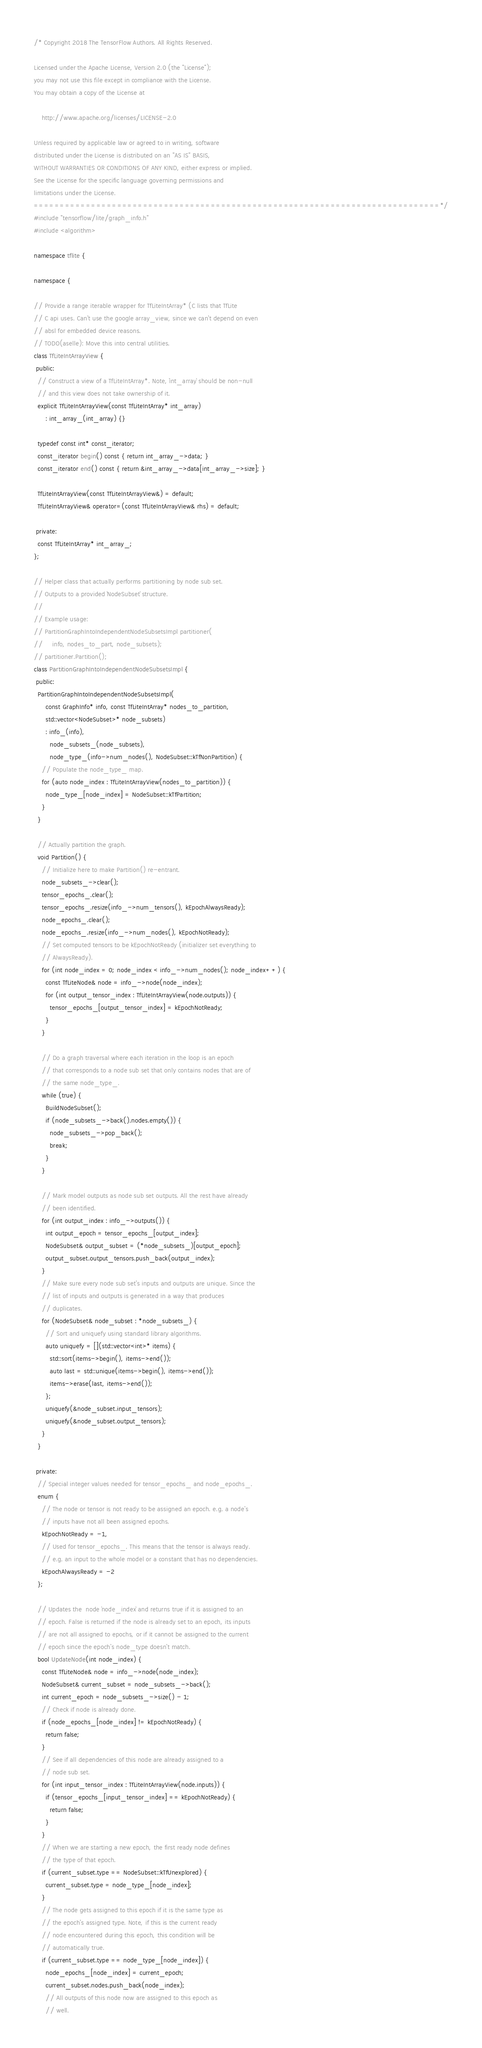<code> <loc_0><loc_0><loc_500><loc_500><_C++_>/* Copyright 2018 The TensorFlow Authors. All Rights Reserved.

Licensed under the Apache License, Version 2.0 (the "License");
you may not use this file except in compliance with the License.
You may obtain a copy of the License at

    http://www.apache.org/licenses/LICENSE-2.0

Unless required by applicable law or agreed to in writing, software
distributed under the License is distributed on an "AS IS" BASIS,
WITHOUT WARRANTIES OR CONDITIONS OF ANY KIND, either express or implied.
See the License for the specific language governing permissions and
limitations under the License.
==============================================================================*/
#include "tensorflow/lite/graph_info.h"
#include <algorithm>

namespace tflite {

namespace {

// Provide a range iterable wrapper for TfLiteIntArray* (C lists that TfLite
// C api uses. Can't use the google array_view, since we can't depend on even
// absl for embedded device reasons.
// TODO(aselle): Move this into central utilities.
class TfLiteIntArrayView {
 public:
  // Construct a view of a TfLiteIntArray*. Note, `int_array` should be non-null
  // and this view does not take ownership of it.
  explicit TfLiteIntArrayView(const TfLiteIntArray* int_array)
      : int_array_(int_array) {}

  typedef const int* const_iterator;
  const_iterator begin() const { return int_array_->data; }
  const_iterator end() const { return &int_array_->data[int_array_->size]; }

  TfLiteIntArrayView(const TfLiteIntArrayView&) = default;
  TfLiteIntArrayView& operator=(const TfLiteIntArrayView& rhs) = default;

 private:
  const TfLiteIntArray* int_array_;
};

// Helper class that actually performs partitioning by node sub set.
// Outputs to a provided `NodeSubset` structure.
//
// Example usage:
// PartitionGraphIntoIndependentNodeSubsetsImpl partitioner(
//     info, nodes_to_part, node_subsets);
// partitioner.Partition();
class PartitionGraphIntoIndependentNodeSubsetsImpl {
 public:
  PartitionGraphIntoIndependentNodeSubsetsImpl(
      const GraphInfo* info, const TfLiteIntArray* nodes_to_partition,
      std::vector<NodeSubset>* node_subsets)
      : info_(info),
        node_subsets_(node_subsets),
        node_type_(info->num_nodes(), NodeSubset::kTfNonPartition) {
    // Populate the node_type_ map.
    for (auto node_index : TfLiteIntArrayView(nodes_to_partition)) {
      node_type_[node_index] = NodeSubset::kTfPartition;
    }
  }

  // Actually partition the graph.
  void Partition() {
    // Initialize here to make Partition() re-entrant.
    node_subsets_->clear();
    tensor_epochs_.clear();
    tensor_epochs_.resize(info_->num_tensors(), kEpochAlwaysReady);
    node_epochs_.clear();
    node_epochs_.resize(info_->num_nodes(), kEpochNotReady);
    // Set computed tensors to be kEpochNotReady (initializer set everything to
    // AlwaysReady).
    for (int node_index = 0; node_index < info_->num_nodes(); node_index++) {
      const TfLiteNode& node = info_->node(node_index);
      for (int output_tensor_index : TfLiteIntArrayView(node.outputs)) {
        tensor_epochs_[output_tensor_index] = kEpochNotReady;
      }
    }

    // Do a graph traversal where each iteration in the loop is an epoch
    // that corresponds to a node sub set that only contains nodes that are of
    // the same node_type_.
    while (true) {
      BuildNodeSubset();
      if (node_subsets_->back().nodes.empty()) {
        node_subsets_->pop_back();
        break;
      }
    }

    // Mark model outputs as node sub set outputs. All the rest have already
    // been identified.
    for (int output_index : info_->outputs()) {
      int output_epoch = tensor_epochs_[output_index];
      NodeSubset& output_subset = (*node_subsets_)[output_epoch];
      output_subset.output_tensors.push_back(output_index);
    }
    // Make sure every node sub set's inputs and outputs are unique. Since the
    // list of inputs and outputs is generated in a way that produces
    // duplicates.
    for (NodeSubset& node_subset : *node_subsets_) {
      // Sort and uniquefy using standard library algorithms.
      auto uniquefy = [](std::vector<int>* items) {
        std::sort(items->begin(), items->end());
        auto last = std::unique(items->begin(), items->end());
        items->erase(last, items->end());
      };
      uniquefy(&node_subset.input_tensors);
      uniquefy(&node_subset.output_tensors);
    }
  }

 private:
  // Special integer values needed for tensor_epochs_ and node_epochs_.
  enum {
    // The node or tensor is not ready to be assigned an epoch. e.g. a node's
    // inputs have not all been assigned epochs.
    kEpochNotReady = -1,
    // Used for tensor_epochs_. This means that the tensor is always ready.
    // e.g. an input to the whole model or a constant that has no dependencies.
    kEpochAlwaysReady = -2
  };

  // Updates the  node `node_index` and returns true if it is assigned to an
  // epoch. False is returned if the node is already set to an epoch, its inputs
  // are not all assigned to epochs, or if it cannot be assigned to the current
  // epoch since the epoch's node_type doesn't match.
  bool UpdateNode(int node_index) {
    const TfLiteNode& node = info_->node(node_index);
    NodeSubset& current_subset = node_subsets_->back();
    int current_epoch = node_subsets_->size() - 1;
    // Check if node is already done.
    if (node_epochs_[node_index] != kEpochNotReady) {
      return false;
    }
    // See if all dependencies of this node are already assigned to a
    // node sub set.
    for (int input_tensor_index : TfLiteIntArrayView(node.inputs)) {
      if (tensor_epochs_[input_tensor_index] == kEpochNotReady) {
        return false;
      }
    }
    // When we are starting a new epoch, the first ready node defines
    // the type of that epoch.
    if (current_subset.type == NodeSubset::kTfUnexplored) {
      current_subset.type = node_type_[node_index];
    }
    // The node gets assigned to this epoch if it is the same type as
    // the epoch's assigned type. Note, if this is the current ready
    // node encountered during this epoch, this condition will be
    // automatically true.
    if (current_subset.type == node_type_[node_index]) {
      node_epochs_[node_index] = current_epoch;
      current_subset.nodes.push_back(node_index);
      // All outputs of this node now are assigned to this epoch as
      // well.</code> 